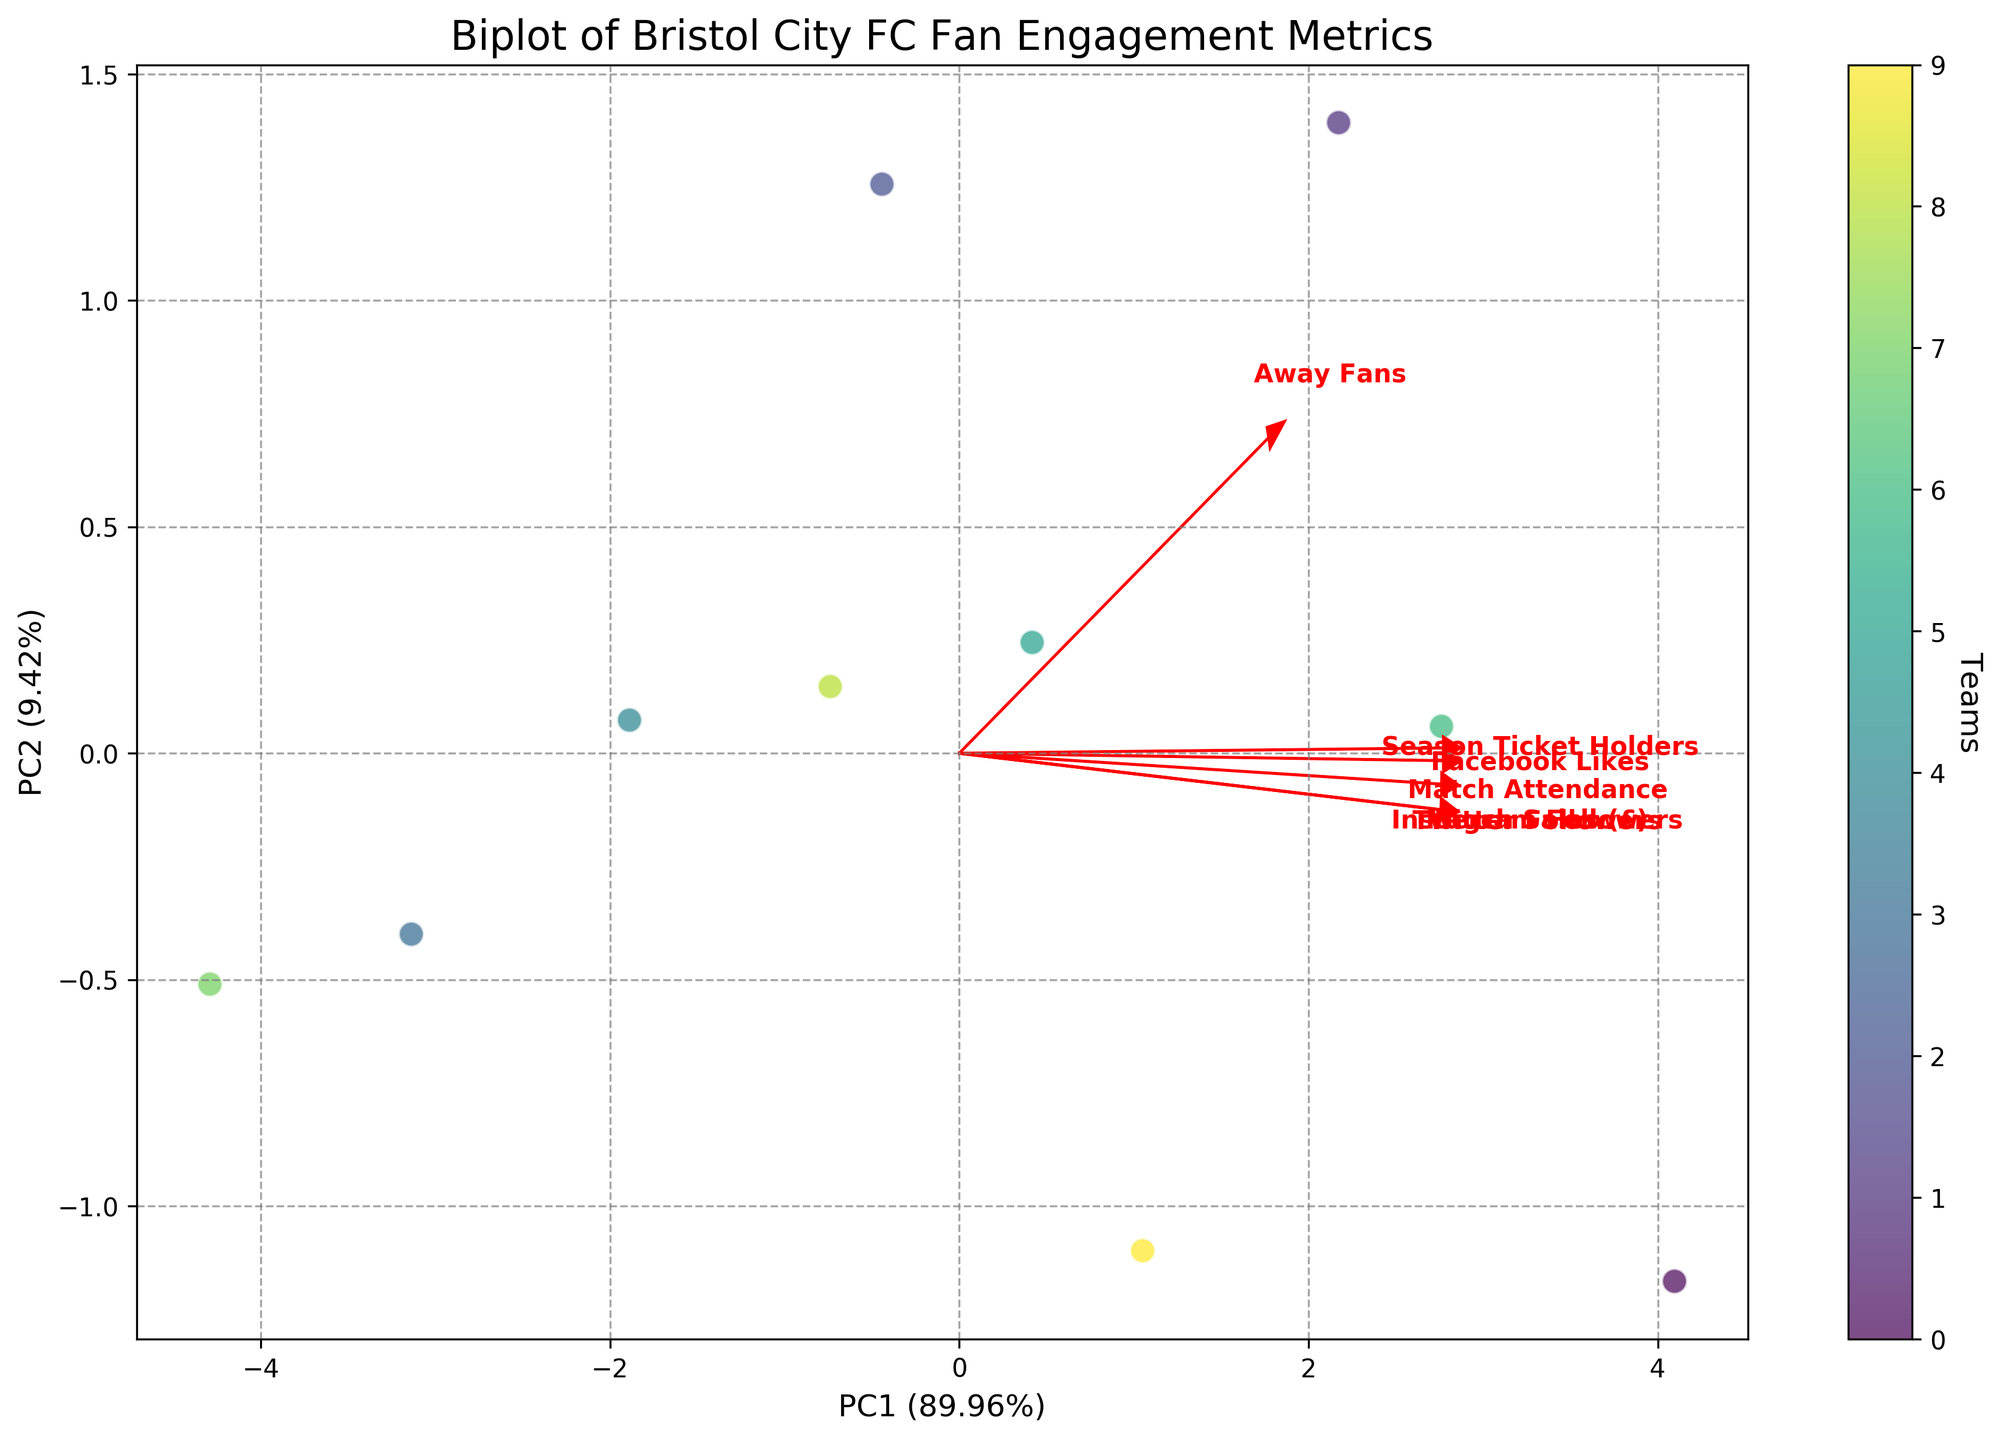What is the title of the biplot? The title is prominently displayed at the top of the figure in a larger font size. It provides a quick summary of what the figure represents.
Answer: Biplot of Bristol City FC Fan Engagement Metrics What do the axes labels represent in this biplot? The axes labels indicate the principal components and the percentage of variance they explain in the data. The x-axis shows PC1 and the y-axis shows PC2 with their corresponding variance percentages.
Answer: PC1 and PC2 with percentages Which team has the highest value on PC1? To identify which team has the highest value on PC1, look at the scatterplot points placed furthest to the right on the x-axis.
Answer: Ashton Gate Which variable contributes most strongly to PC2? To determine this, look at the direction in which the eigenvectors (arrows) point most prominently along the y-axis (PC2).
Answer: Season Ticket Holders How many teams are represented in the scatterplot? Each scatter point represents a team. Count the number of distinct points on the scatterplot.
Answer: 10 Which variables seem positively correlated with match attendance? Positive correlation can be inferred if the arrows for the variables are pointing in the same direction as the arrow for match attendance.
Answer: Twitter Followers, Instagram Followers, Facebook Likes, Merch Sales How can you tell which principal component explains more variance? Compare the percentages indicated on the x-axis and y-axis labels. The larger percentage corresponds to the component explaining more variance.
Answer: PC1 Which variables are negatively correlated with away fans? Negative correlation is indicated by arrows pointing in opposite directions to the arrow for away fans. Check the direction of arrows relative to the away fans arrow.
Answer: Millwall, Plymouth Argyle 